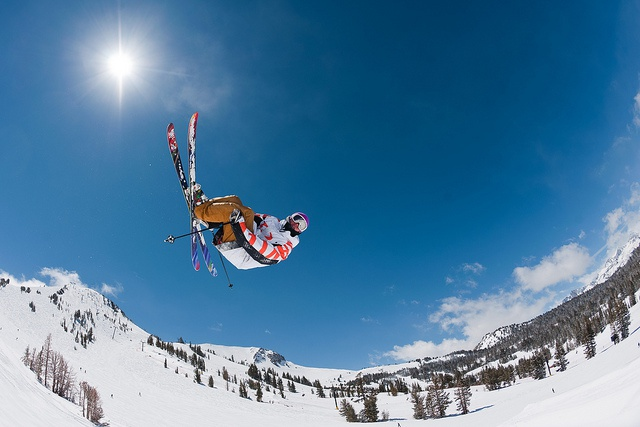Describe the objects in this image and their specific colors. I can see people in blue, lightgray, black, brown, and darkgray tones and skis in blue, teal, black, lightgray, and gray tones in this image. 